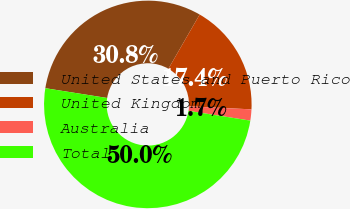Convert chart to OTSL. <chart><loc_0><loc_0><loc_500><loc_500><pie_chart><fcel>United States and Puerto Rico<fcel>United Kingdom<fcel>Australia<fcel>Total<nl><fcel>30.83%<fcel>17.43%<fcel>1.74%<fcel>50.0%<nl></chart> 